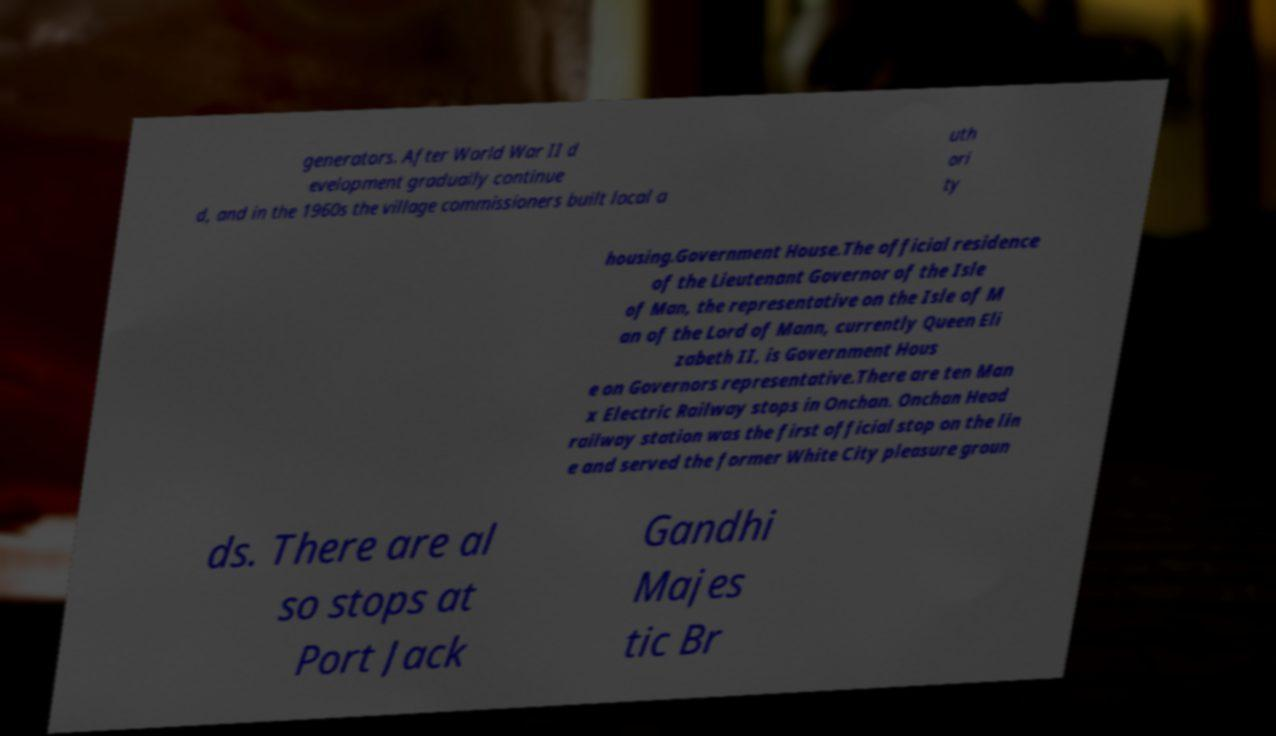Can you read and provide the text displayed in the image?This photo seems to have some interesting text. Can you extract and type it out for me? generators. After World War II d evelopment gradually continue d, and in the 1960s the village commissioners built local a uth ori ty housing.Government House.The official residence of the Lieutenant Governor of the Isle of Man, the representative on the Isle of M an of the Lord of Mann, currently Queen Eli zabeth II, is Government Hous e on Governors representative.There are ten Man x Electric Railway stops in Onchan. Onchan Head railway station was the first official stop on the lin e and served the former White City pleasure groun ds. There are al so stops at Port Jack Gandhi Majes tic Br 